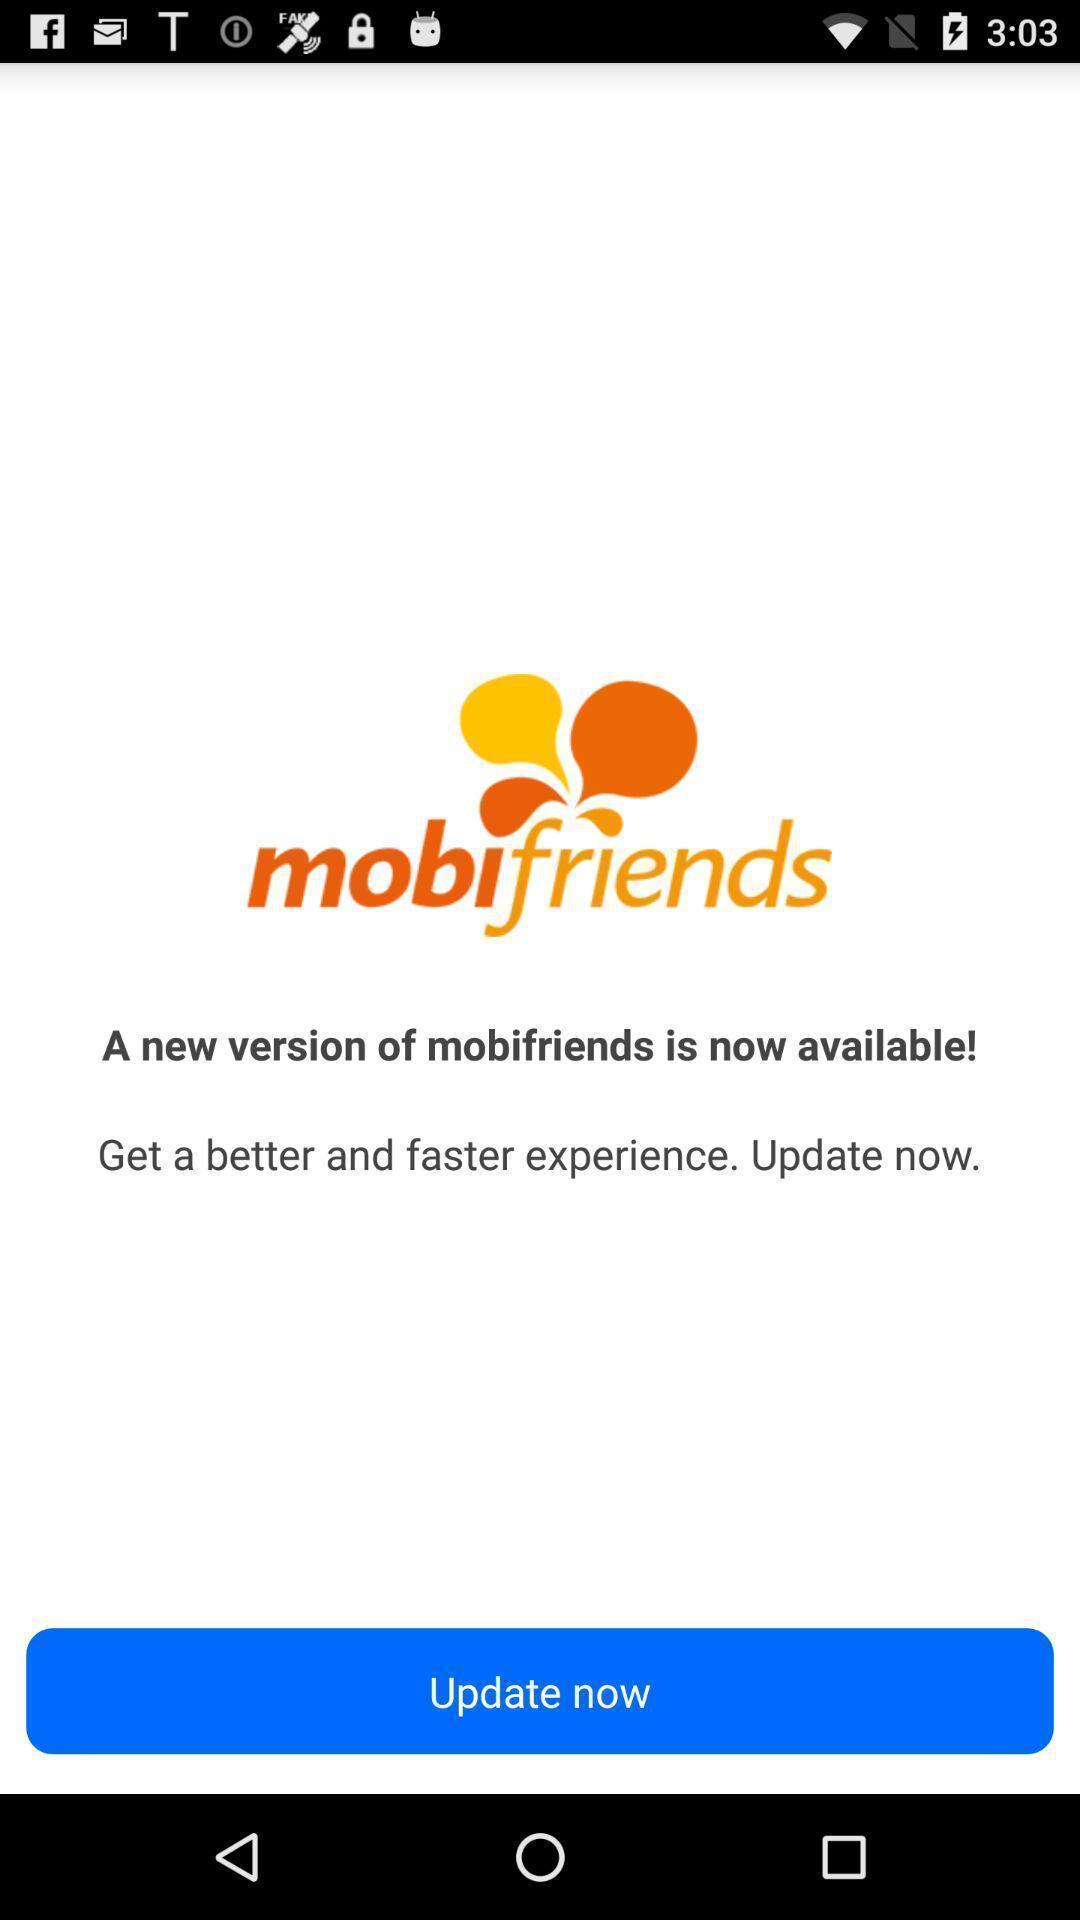Describe the content in this image. Welcome page. 